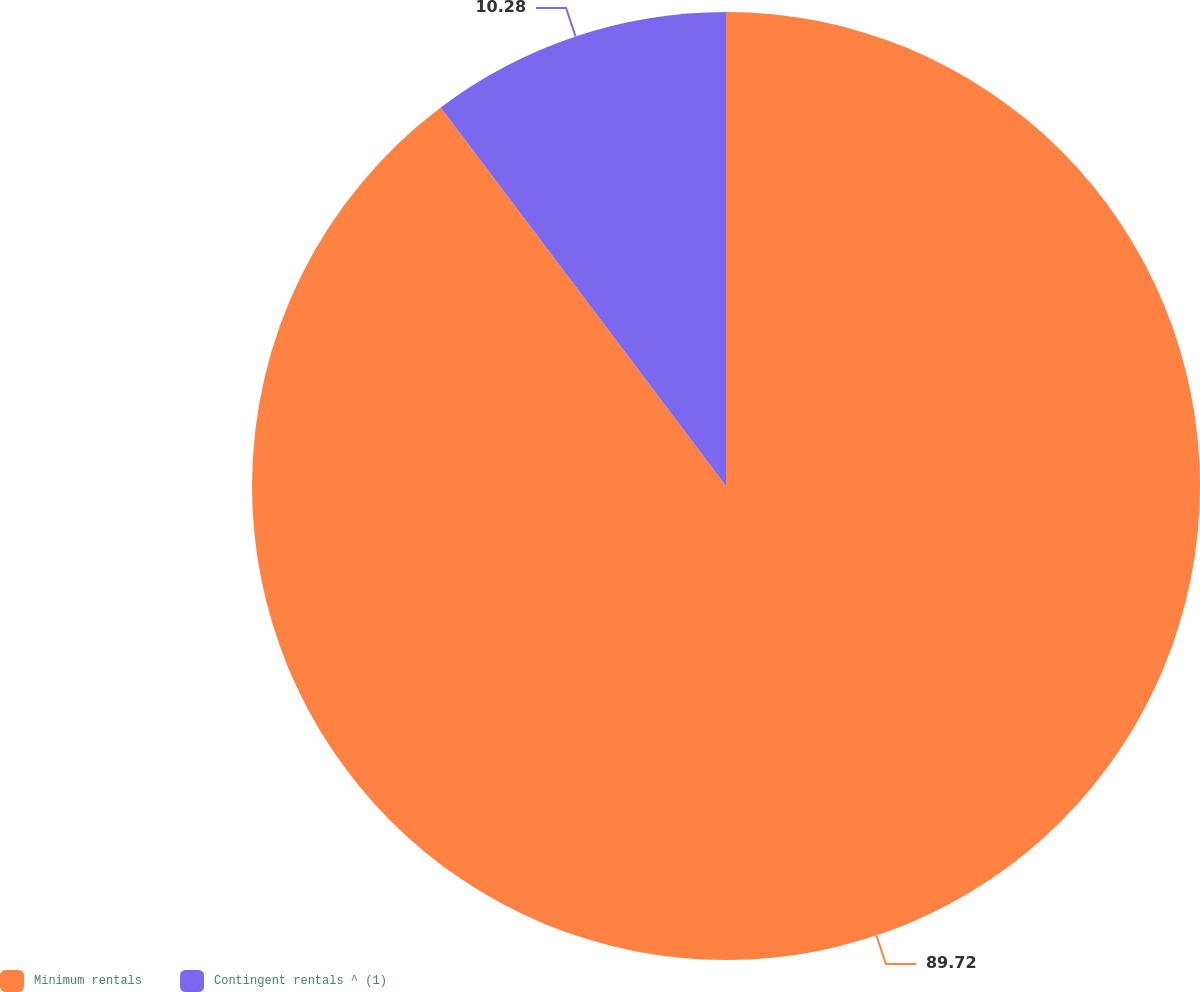Convert chart to OTSL. <chart><loc_0><loc_0><loc_500><loc_500><pie_chart><fcel>Minimum rentals<fcel>Contingent rentals ^ (1)<nl><fcel>89.72%<fcel>10.28%<nl></chart> 